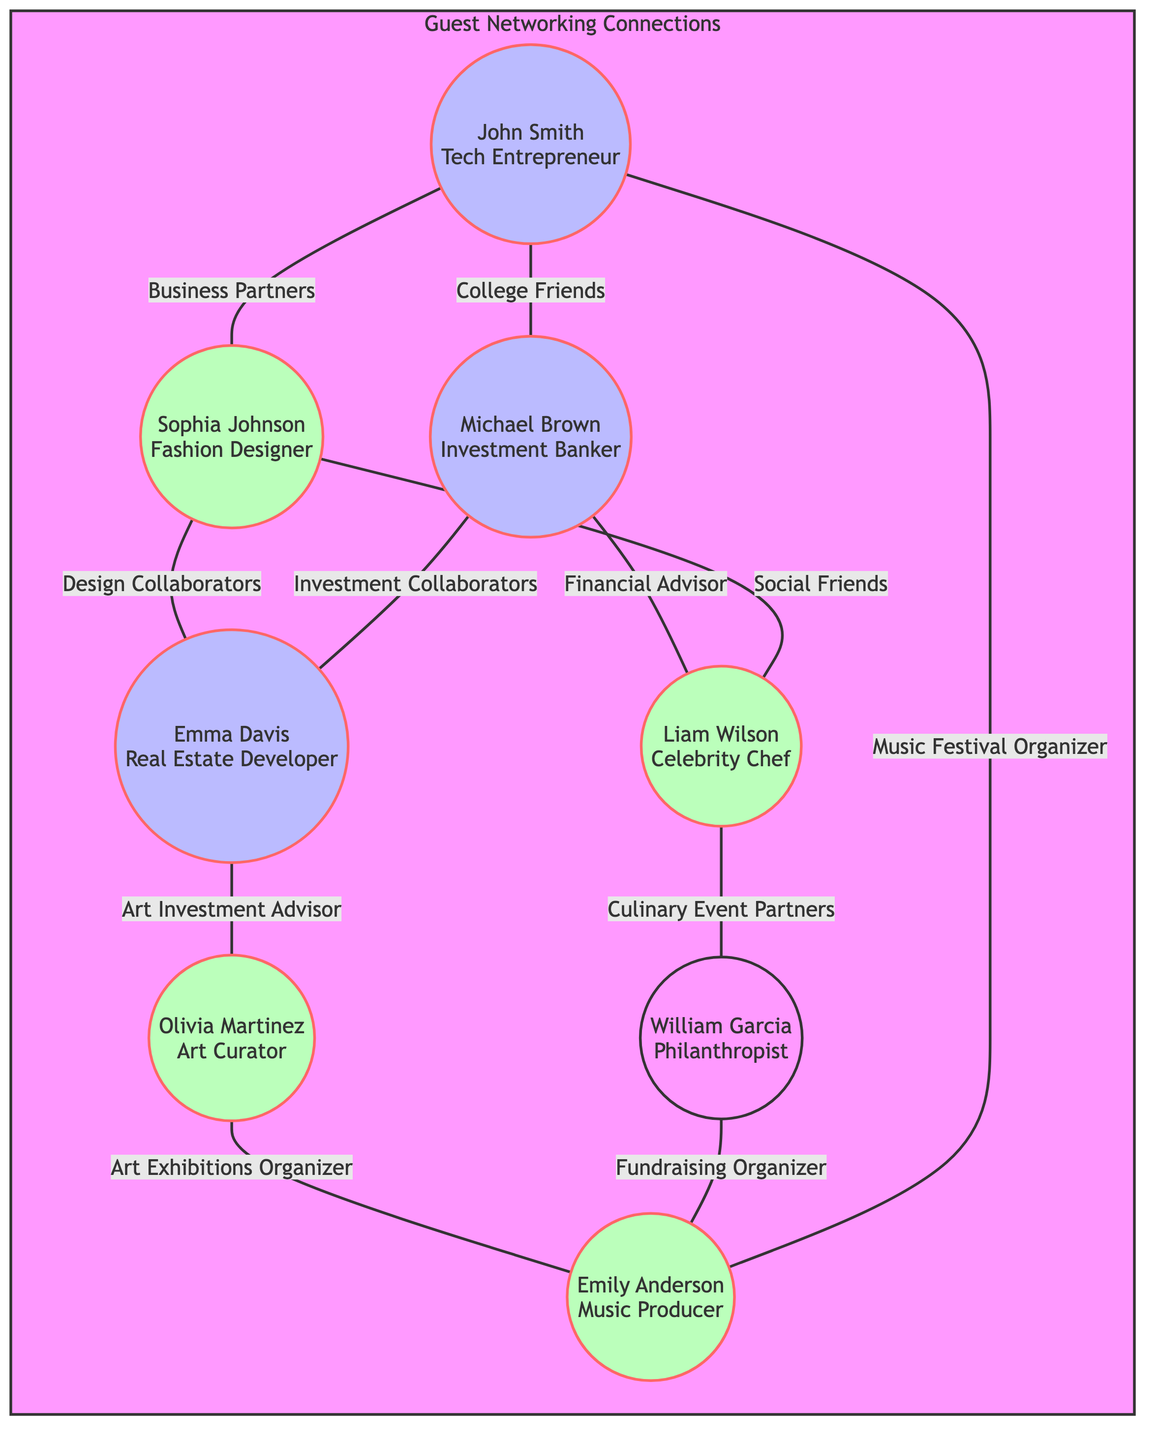What is the occupation of John Smith? The diagram indicates that John Smith is labeled as a Tech Entrepreneur, which directly identifies his occupation.
Answer: Tech Entrepreneur How many nodes are present in the diagram? The diagram has a total of eight nodes, each representing a guest at the cocktail parties. This is indicated by the individual circles for each guest.
Answer: 8 What is the relationship between Emma Davis and Olivia Martinez? By examining the edges, it shows that Emma Davis is connected to Olivia Martinez, and the relationship is specified as Art Investment Advisor.
Answer: Art Investment Advisor Who are the Culinary Event Partners? The edge connecting Liam Wilson and William Garcia specifies the relationship as Culinary Event Partners, indicating they collaborate on culinary events.
Answer: Liam Wilson, William Garcia Which guests are connected to Michael Brown? The relationships include connections to John Smith, Liam Wilson, and Emma Davis, denoting college friendships and investment collaborations. Each of these connections can be traced directly through the edges leading from Michael Brown.
Answer: John Smith, Liam Wilson, Emma Davis Does Sophia Johnson have a professional relationship with Liam Wilson? The diagram shows an edge connecting Sophia Johnson with Liam Wilson, identified as Social Friends, which indicates a personal rather than a strictly professional relationship.
Answer: Yes How many edges are depicting professional relationships? By analyzing the connections, there are five edges that denote professional relationships among the guests, indicating collaborations or advisory roles.
Answer: 5 Which guest is connected to the most other guests? Assessing the nodes, Michael Brown connects to three other guests (John Smith, Emma Davis, and Liam Wilson). This makes him the most connected guest in the diagram.
Answer: Michael Brown Is there a connection between William Garcia and Emily Anderson? The edge between William Garcia and Emily Anderson shows that they are connected through the relationship of being Fundraising Organizer, confirming that they work together for fundraising events.
Answer: Yes 